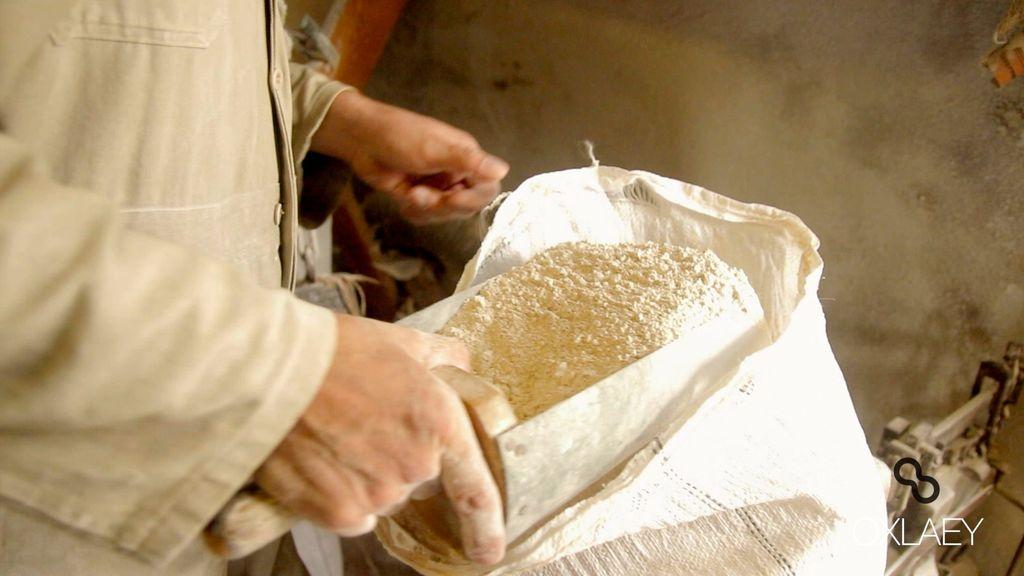What is the primary subject of the image? There is a human in the image. What is the human doing in the image? The human is taking out flour from a bag. Can you describe any additional features of the image? There is a watermark in the bottom right-hand side of the image. What type of riddle can be solved by looking at the ocean in the image? There is no ocean present in the image, and therefore no riddle related to the ocean can be solved. 